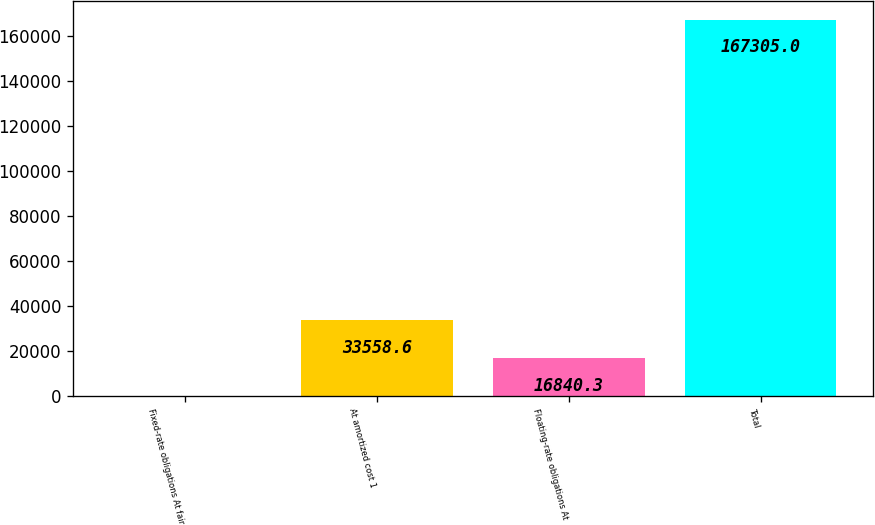<chart> <loc_0><loc_0><loc_500><loc_500><bar_chart><fcel>Fixed-rate obligations At fair<fcel>At amortized cost 1<fcel>Floating-rate obligations At<fcel>Total<nl><fcel>122<fcel>33558.6<fcel>16840.3<fcel>167305<nl></chart> 